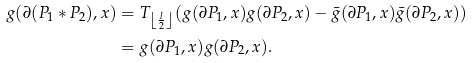Convert formula to latex. <formula><loc_0><loc_0><loc_500><loc_500>g ( \partial ( P _ { 1 } * P _ { 2 } ) , x ) & = T _ { \left \lfloor \frac { l } { 2 } \right \rfloor } ( g ( \partial P _ { 1 } , x ) g ( \partial P _ { 2 } , x ) - \bar { g } ( \partial P _ { 1 } , x ) \bar { g } ( \partial P _ { 2 } , x ) ) \\ & = g ( \partial P _ { 1 } , x ) g ( \partial P _ { 2 } , x ) .</formula> 